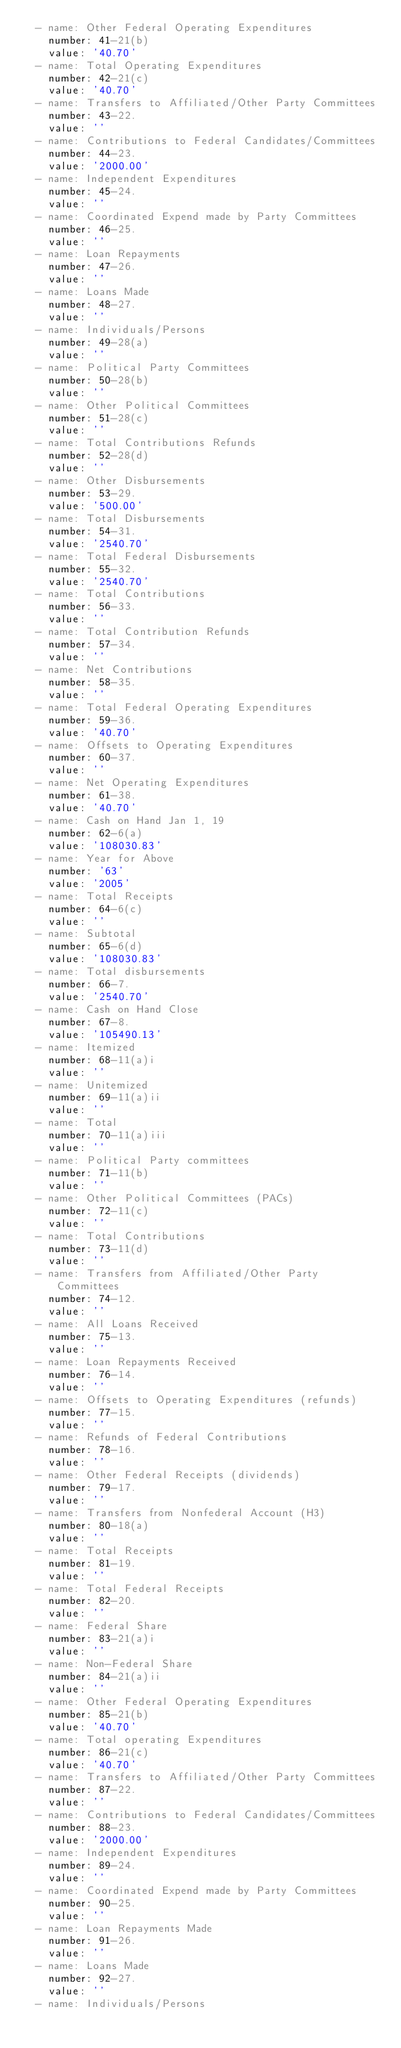<code> <loc_0><loc_0><loc_500><loc_500><_YAML_>  - name: Other Federal Operating Expenditures
    number: 41-21(b)
    value: '40.70'
  - name: Total Operating Expenditures
    number: 42-21(c)
    value: '40.70'
  - name: Transfers to Affiliated/Other Party Committees
    number: 43-22.
    value: ''
  - name: Contributions to Federal Candidates/Committees
    number: 44-23.
    value: '2000.00'
  - name: Independent Expenditures
    number: 45-24.
    value: ''
  - name: Coordinated Expend made by Party Committees
    number: 46-25.
    value: ''
  - name: Loan Repayments
    number: 47-26.
    value: ''
  - name: Loans Made
    number: 48-27.
    value: ''
  - name: Individuals/Persons
    number: 49-28(a)
    value: ''
  - name: Political Party Committees
    number: 50-28(b)
    value: ''
  - name: Other Political Committees
    number: 51-28(c)
    value: ''
  - name: Total Contributions Refunds
    number: 52-28(d)
    value: ''
  - name: Other Disbursements
    number: 53-29.
    value: '500.00'
  - name: Total Disbursements
    number: 54-31.
    value: '2540.70'
  - name: Total Federal Disbursements
    number: 55-32.
    value: '2540.70'
  - name: Total Contributions
    number: 56-33.
    value: ''
  - name: Total Contribution Refunds
    number: 57-34.
    value: ''
  - name: Net Contributions
    number: 58-35.
    value: ''
  - name: Total Federal Operating Expenditures
    number: 59-36.
    value: '40.70'
  - name: Offsets to Operating Expenditures
    number: 60-37.
    value: ''
  - name: Net Operating Expenditures
    number: 61-38.
    value: '40.70'
  - name: Cash on Hand Jan 1, 19
    number: 62-6(a)
    value: '108030.83'
  - name: Year for Above
    number: '63'
    value: '2005'
  - name: Total Receipts
    number: 64-6(c)
    value: ''
  - name: Subtotal
    number: 65-6(d)
    value: '108030.83'
  - name: Total disbursements
    number: 66-7.
    value: '2540.70'
  - name: Cash on Hand Close
    number: 67-8.
    value: '105490.13'
  - name: Itemized
    number: 68-11(a)i
    value: ''
  - name: Unitemized
    number: 69-11(a)ii
    value: ''
  - name: Total
    number: 70-11(a)iii
    value: ''
  - name: Political Party committees
    number: 71-11(b)
    value: ''
  - name: Other Political Committees (PACs)
    number: 72-11(c)
    value: ''
  - name: Total Contributions
    number: 73-11(d)
    value: ''
  - name: Transfers from Affiliated/Other Party Committees
    number: 74-12.
    value: ''
  - name: All Loans Received
    number: 75-13.
    value: ''
  - name: Loan Repayments Received
    number: 76-14.
    value: ''
  - name: Offsets to Operating Expenditures (refunds)
    number: 77-15.
    value: ''
  - name: Refunds of Federal Contributions
    number: 78-16.
    value: ''
  - name: Other Federal Receipts (dividends)
    number: 79-17.
    value: ''
  - name: Transfers from Nonfederal Account (H3)
    number: 80-18(a)
    value: ''
  - name: Total Receipts
    number: 81-19.
    value: ''
  - name: Total Federal Receipts
    number: 82-20.
    value: ''
  - name: Federal Share
    number: 83-21(a)i
    value: ''
  - name: Non-Federal Share
    number: 84-21(a)ii
    value: ''
  - name: Other Federal Operating Expenditures
    number: 85-21(b)
    value: '40.70'
  - name: Total operating Expenditures
    number: 86-21(c)
    value: '40.70'
  - name: Transfers to Affiliated/Other Party Committees
    number: 87-22.
    value: ''
  - name: Contributions to Federal Candidates/Committees
    number: 88-23.
    value: '2000.00'
  - name: Independent Expenditures
    number: 89-24.
    value: ''
  - name: Coordinated Expend made by Party Committees
    number: 90-25.
    value: ''
  - name: Loan Repayments Made
    number: 91-26.
    value: ''
  - name: Loans Made
    number: 92-27.
    value: ''
  - name: Individuals/Persons</code> 